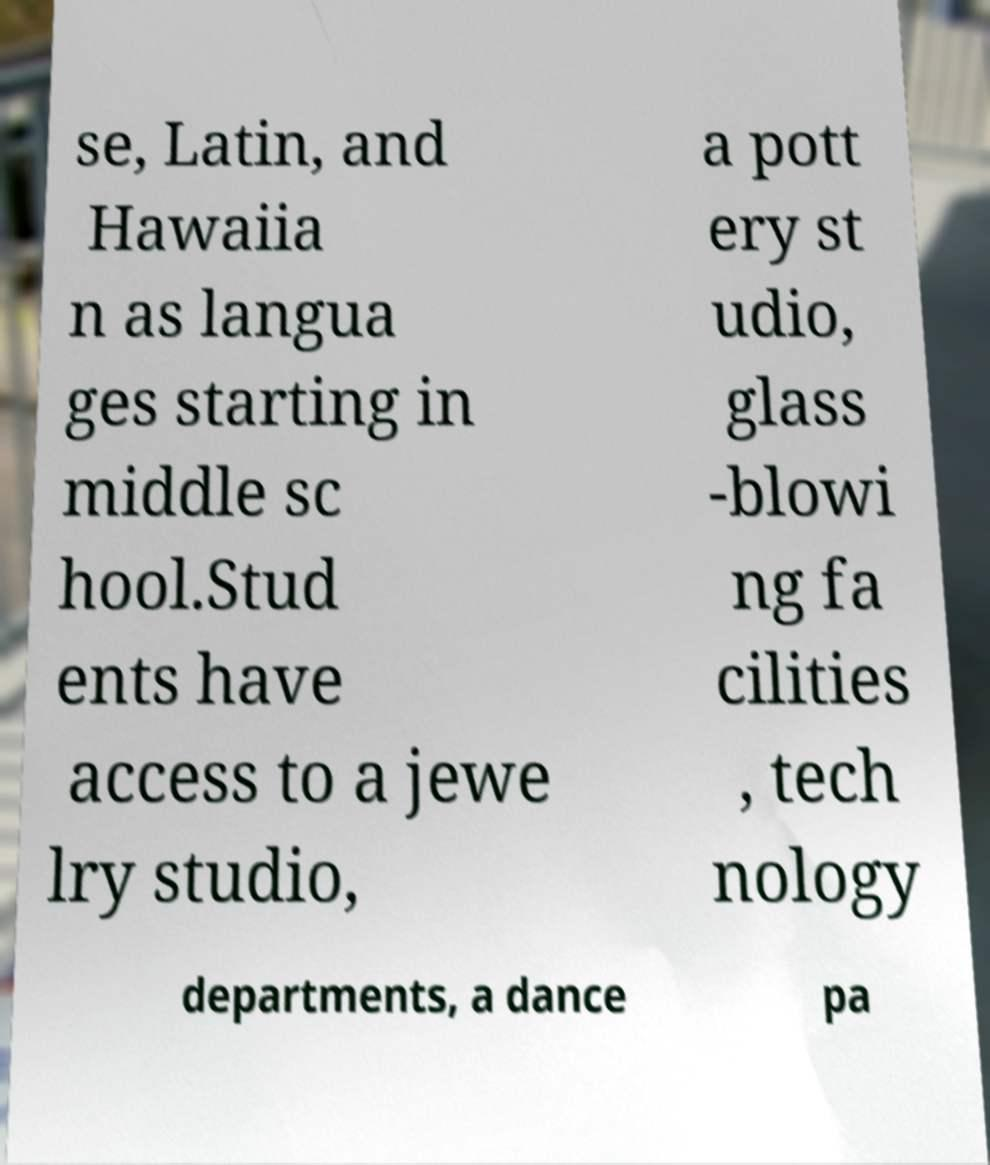Could you assist in decoding the text presented in this image and type it out clearly? se, Latin, and Hawaiia n as langua ges starting in middle sc hool.Stud ents have access to a jewe lry studio, a pott ery st udio, glass -blowi ng fa cilities , tech nology departments, a dance pa 